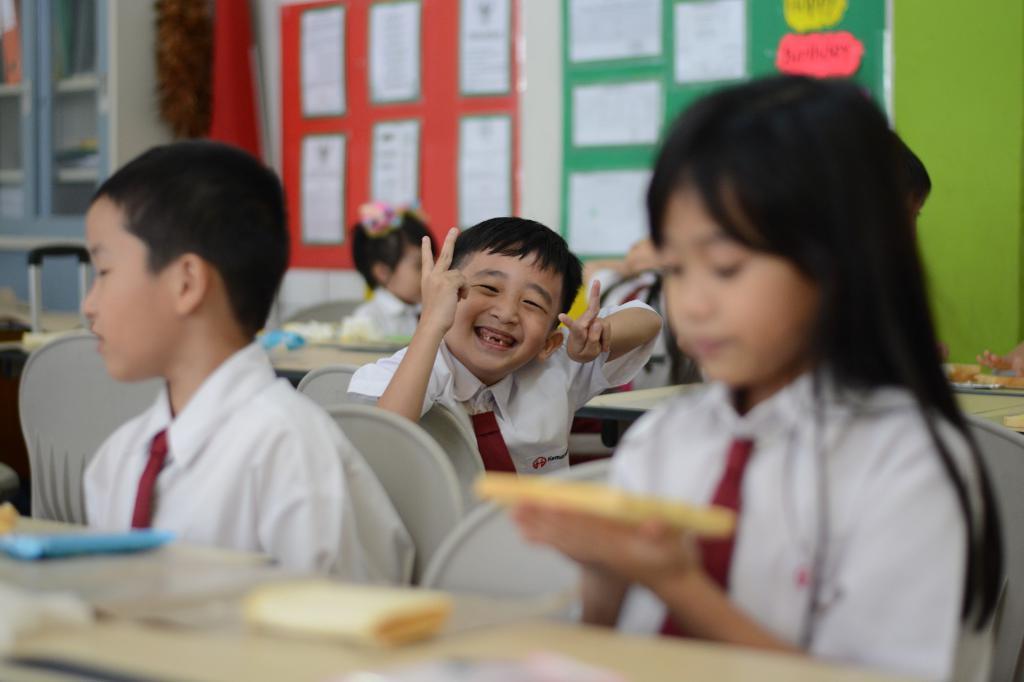How would you summarize this image in a sentence or two? In this picture we can see group of people, they are all seated on the chairs, in front of them we can see food and other things on the tables, in the background we can find few boards on the wall, and we can see a boy in the middle of the image, he is smiling. 